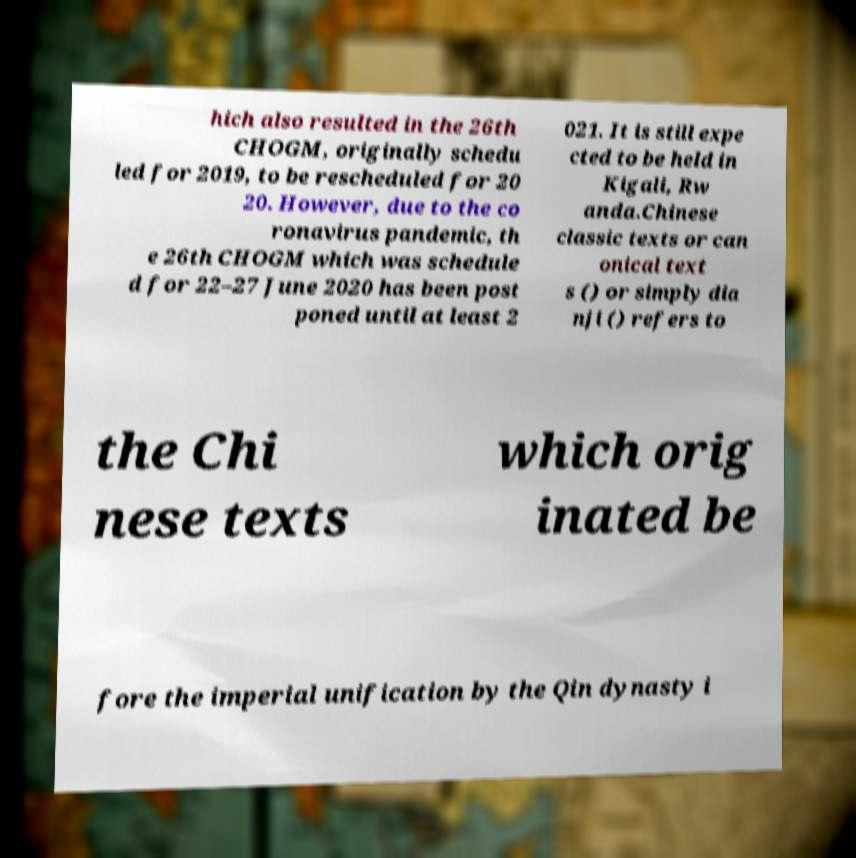Please read and relay the text visible in this image. What does it say? hich also resulted in the 26th CHOGM, originally schedu led for 2019, to be rescheduled for 20 20. However, due to the co ronavirus pandemic, th e 26th CHOGM which was schedule d for 22–27 June 2020 has been post poned until at least 2 021. It is still expe cted to be held in Kigali, Rw anda.Chinese classic texts or can onical text s () or simply dia nji () refers to the Chi nese texts which orig inated be fore the imperial unification by the Qin dynasty i 